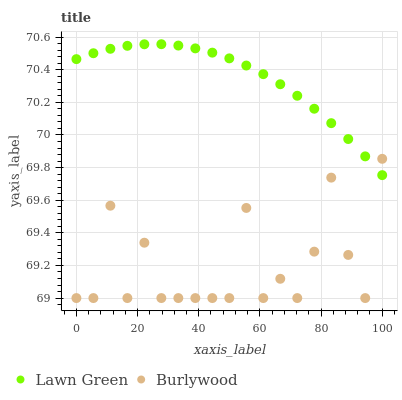Does Burlywood have the minimum area under the curve?
Answer yes or no. Yes. Does Lawn Green have the maximum area under the curve?
Answer yes or no. Yes. Does Lawn Green have the minimum area under the curve?
Answer yes or no. No. Is Lawn Green the smoothest?
Answer yes or no. Yes. Is Burlywood the roughest?
Answer yes or no. Yes. Is Lawn Green the roughest?
Answer yes or no. No. Does Burlywood have the lowest value?
Answer yes or no. Yes. Does Lawn Green have the lowest value?
Answer yes or no. No. Does Lawn Green have the highest value?
Answer yes or no. Yes. Does Burlywood intersect Lawn Green?
Answer yes or no. Yes. Is Burlywood less than Lawn Green?
Answer yes or no. No. Is Burlywood greater than Lawn Green?
Answer yes or no. No. 